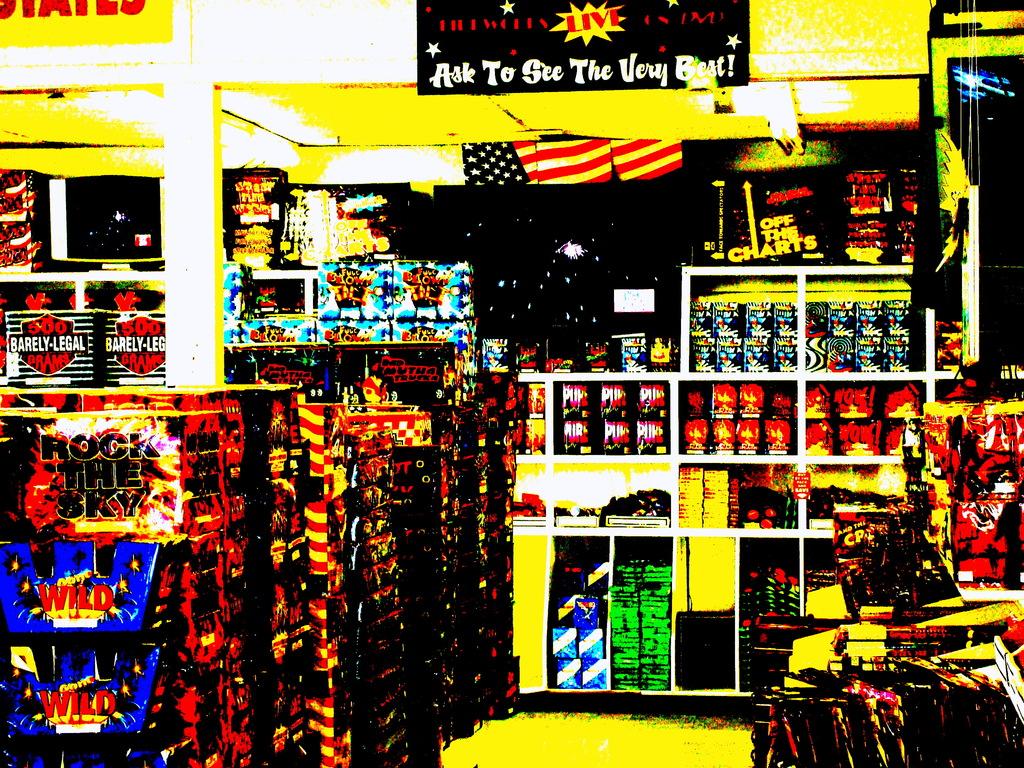What is the word after barely on the sign to the far left?
Ensure brevity in your answer.  Legal. What should you ask to see?
Keep it short and to the point. The very best. 